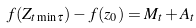<formula> <loc_0><loc_0><loc_500><loc_500>f ( Z _ { t \min \tau } ) - f ( z _ { 0 } ) = M _ { t } + A _ { t }</formula> 